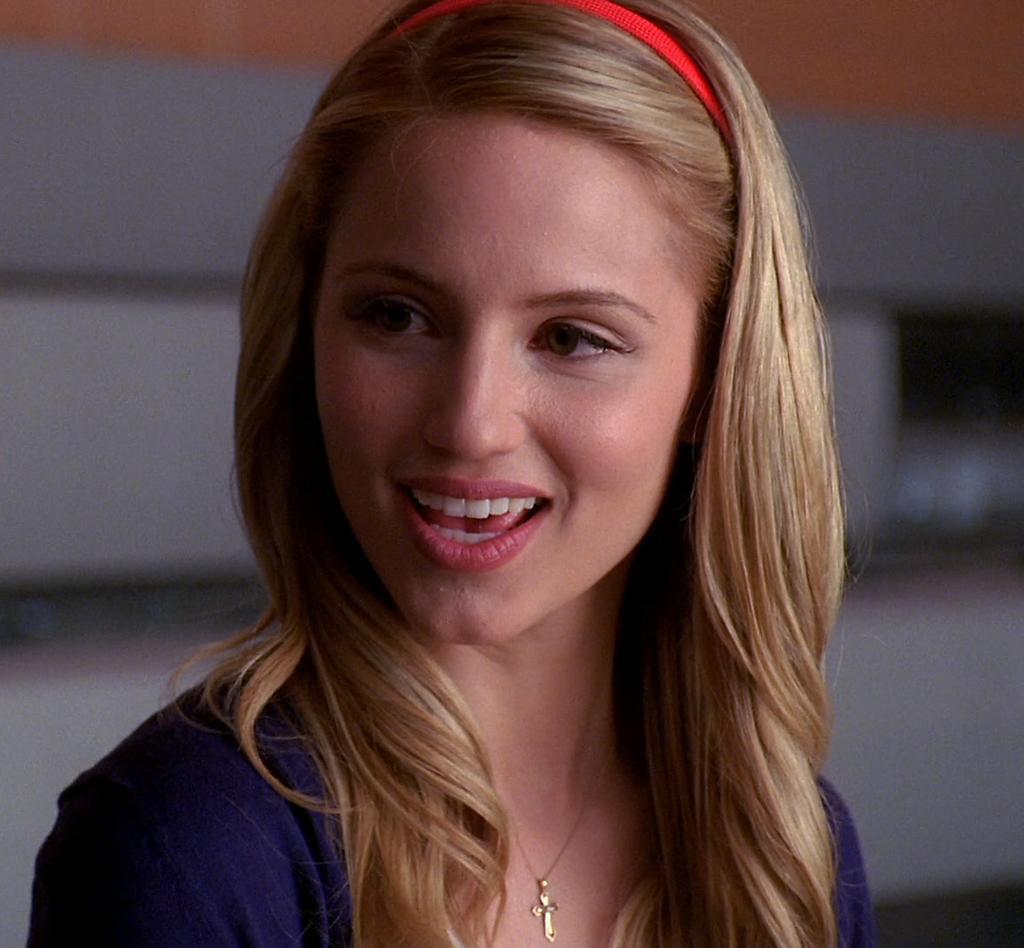In one or two sentences, can you explain what this image depicts? In this image in the foreground there is one woman who is wearing a headband and it seems that she is talking, and there is a blurry background. 